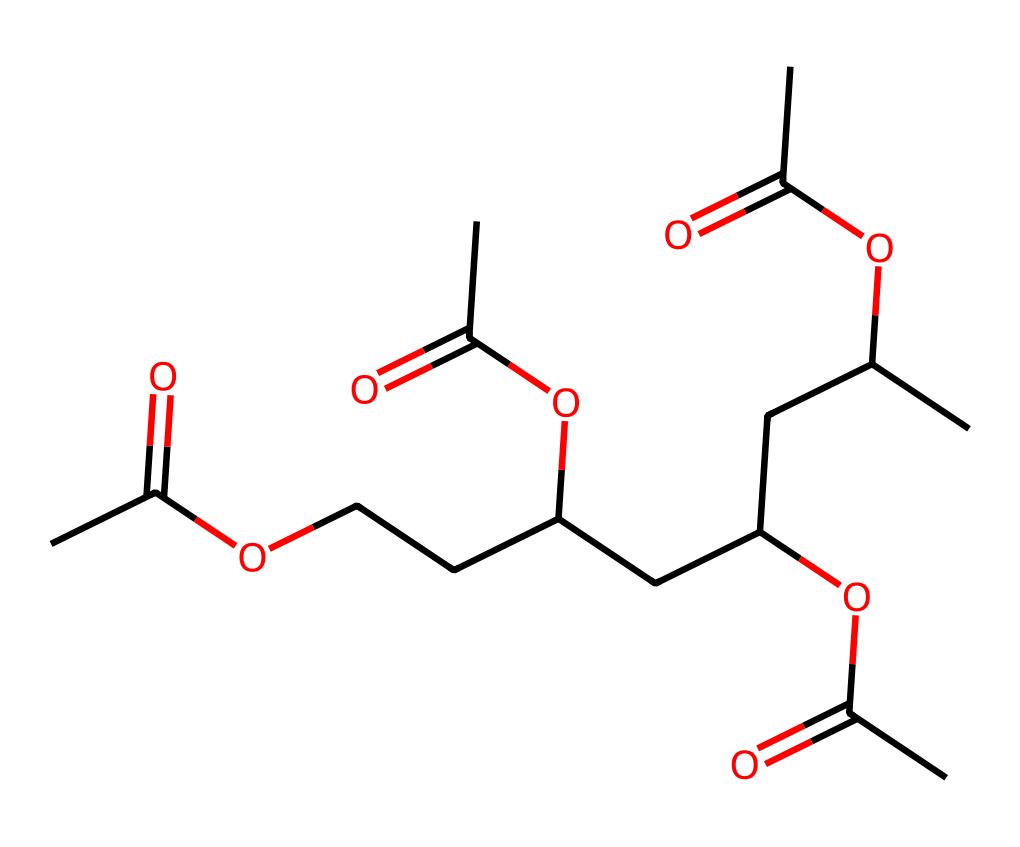What is the primary functional group present in this polymer structure? The chemical structure contains multiple ester groups as indicated by the segments "OC(=O)" throughout the chain. This is characteristic of polyesters, which use esters as their main functional groups.
Answer: ester How many carbon atoms are present in this polymer? By counting the carbon atoms in the provided SMILES representation, there are a total of 20 carbon atoms represented in the structure.
Answer: 20 What type of bond connects the ester functional groups to the polymer backbone? The bond connecting the ester groups to the polymer backbone is an ester bond, which is a result of a reaction between a carboxylic acid and an alcohol.
Answer: ester bond How many identical repeating units are shown in the polymer chain? Upon analysis of the structure, there are four identical repeating units (each portion "CC(OC(=O)C)") in the polymer chain.
Answer: 4 What is the degree of polymerization based on the structure provided? The degree of polymerization refers to the number of monomeric units that make up the polymer; in this case, it is determined to be 4, matching the number of repeating units identified earlier.
Answer: 4 Which type of polymer does this structure represent? This chemical represents a polyester due to the presence of repeating ester linkages and the structure's typical features of a polyester.
Answer: polyester 